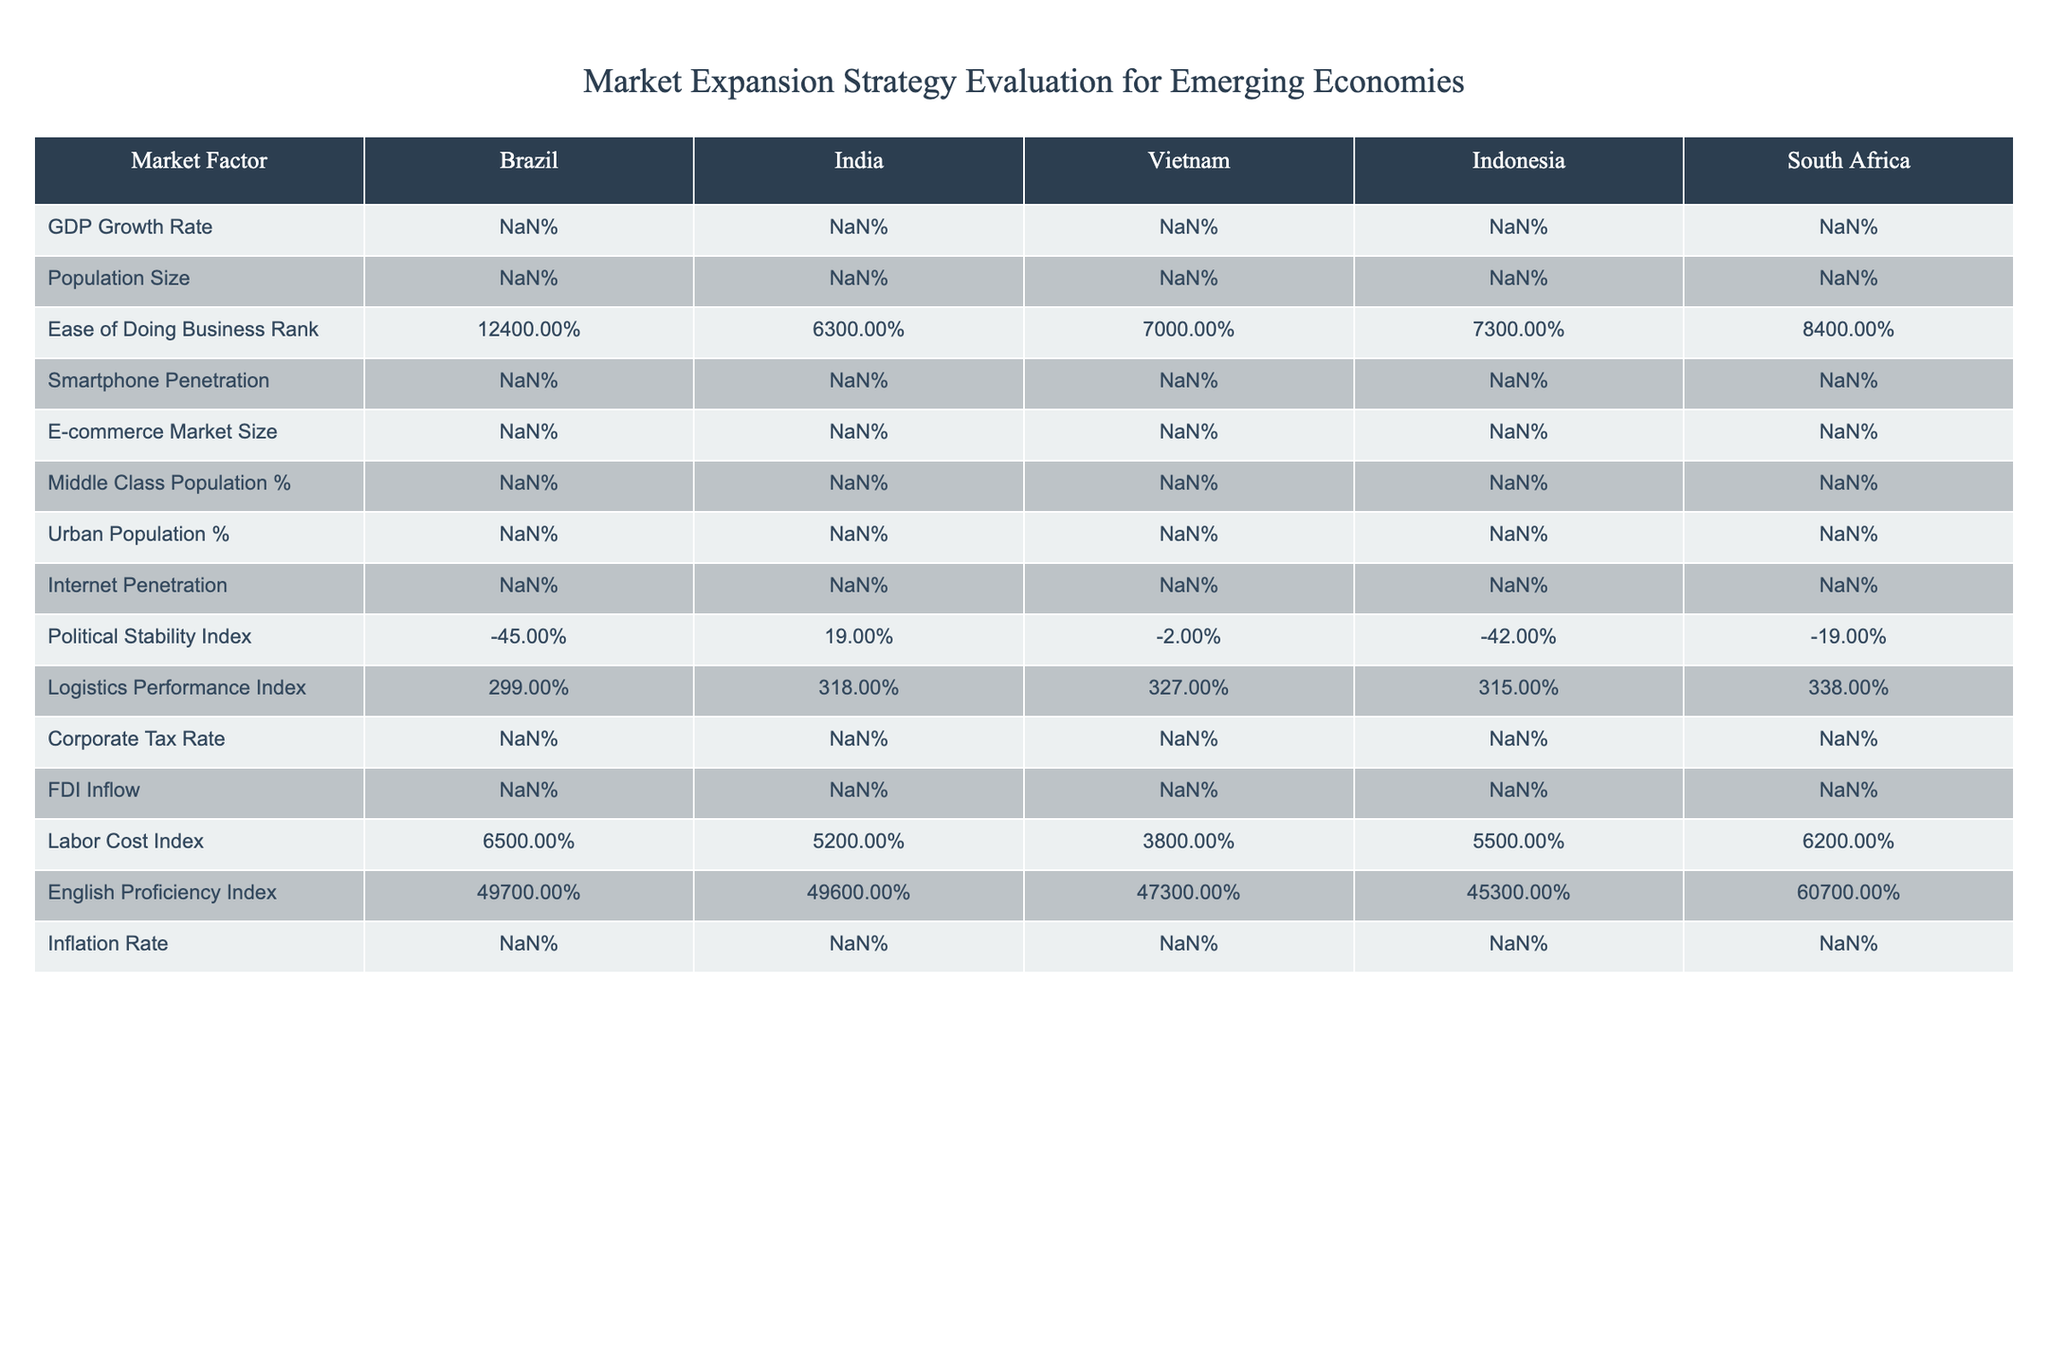What is the GDP growth rate in India? The table provides a direct value under the 'GDP Growth Rate' column for India, which is 6.1%.
Answer: 6.1% Which country has the highest e-commerce market size? By looking at the 'E-commerce Market Size' column, Brazil, with a market size of $19B, India with $64B, Vietnam at $12B, Indonesia at $32B, and South Africa at $4B, India has the highest market size at $64B.
Answer: India Is the population in Brazil larger than in South Africa? The population sizes in the table show Brazil at 212M and South Africa at 59M. Since 212M is greater than 59M, the answer is yes.
Answer: Yes What is the average ease of doing business rank for the countries listed? To find the average, sum the ranks (124 + 63 + 70 + 73 + 84) = 414, then divide by the number of countries (5). So, 414/5 = 82.8
Answer: 82.8 Does Vietnam have a higher smartphone penetration than Indonesia? The smartphone penetration for Vietnam is 63%, while for Indonesia it is 67%. Since 63% is less than 67%, the answer is no.
Answer: No What is the difference in logistic performance index between South Africa and Brazil? For South Africa, the Logistics Performance Index is 3.38 and for Brazil, it is 2.99. The difference is 3.38 - 2.99 = 0.39.
Answer: 0.39 Which country shows the lowest political stability index? Checking the 'Political Stability Index', Brazil is at -0.45 which is lower than the other countries listed, making it the country with the lowest index.
Answer: Brazil Is the inflation rate in Indonesia lower than that in South Africa? The table lists the inflation rates: Indonesia is 3.0% and South Africa is 4.1%. Since 3.0% is less than 4.1%, the answer is yes.
Answer: Yes What is the Internet penetration rate average for the five countries? The Internet penetration rates are 74%, 50%, 70%, 64%, and 56%. Summing these gives 314. Dividing by 5 gives an average of 62.8%.
Answer: 62.8% 